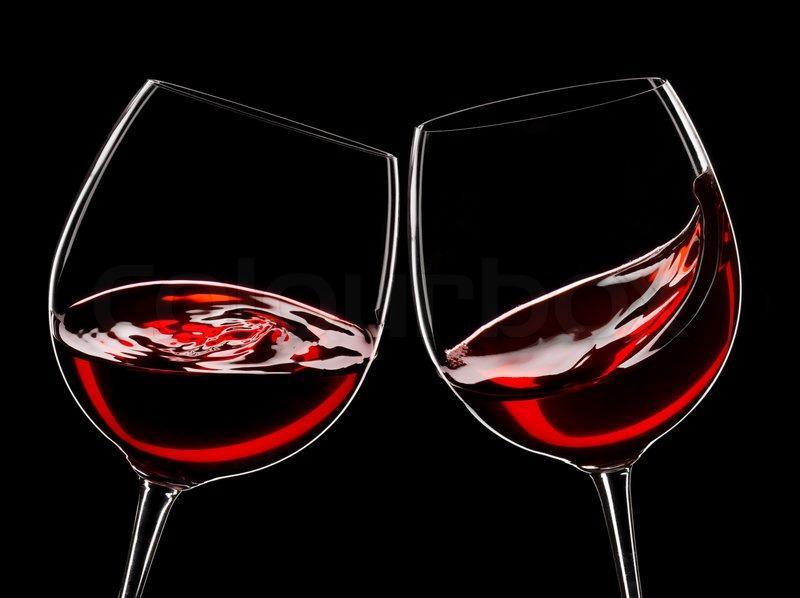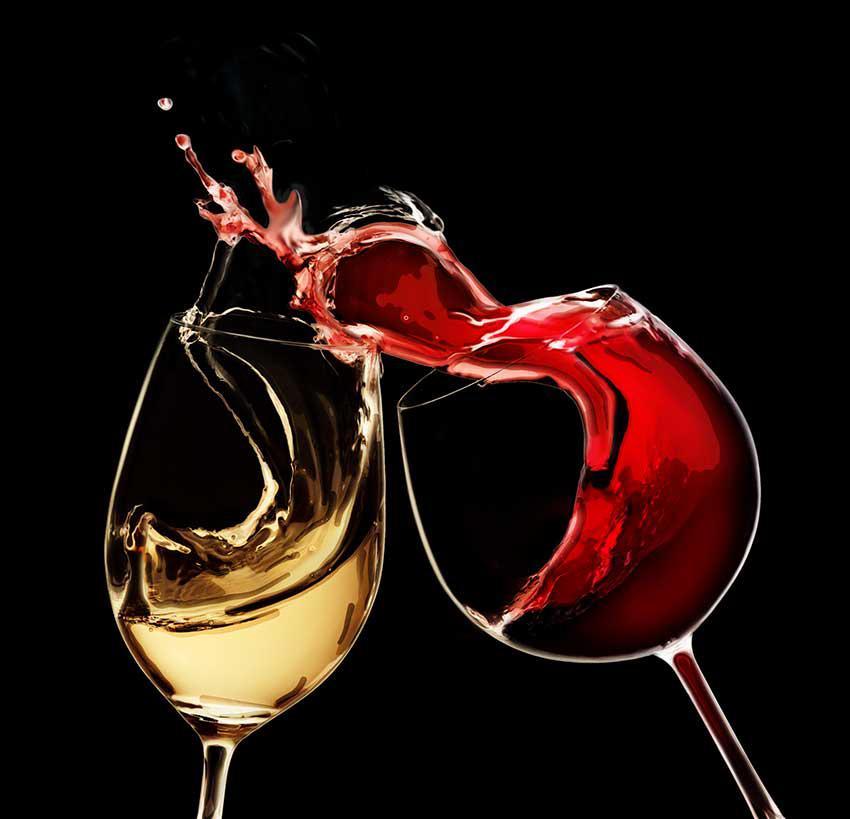The first image is the image on the left, the second image is the image on the right. Analyze the images presented: Is the assertion "A pair of clinking wine glasses create a splash of wine that reaches above the rim of the glass." valid? Answer yes or no. Yes. The first image is the image on the left, the second image is the image on the right. Assess this claim about the two images: "The right image contains two wine glasses with red wine in them.". Correct or not? Answer yes or no. No. 